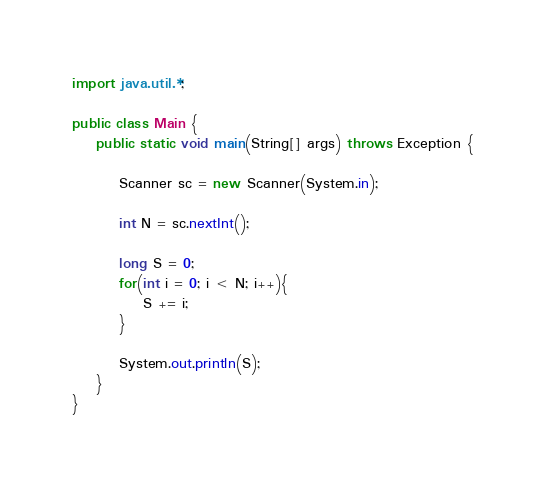<code> <loc_0><loc_0><loc_500><loc_500><_Java_>import java.util.*;

public class Main {
    public static void main(String[] args) throws Exception {
        
        Scanner sc = new Scanner(System.in);
        
        int N = sc.nextInt();
        
        long S = 0;
        for(int i = 0; i < N; i++){
            S += i;
        }
        
        System.out.println(S);
    }
}

</code> 